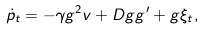Convert formula to latex. <formula><loc_0><loc_0><loc_500><loc_500>\dot { p } _ { t } = - \gamma g ^ { 2 } v + D g g ^ { \prime } + g \xi _ { t } ,</formula> 